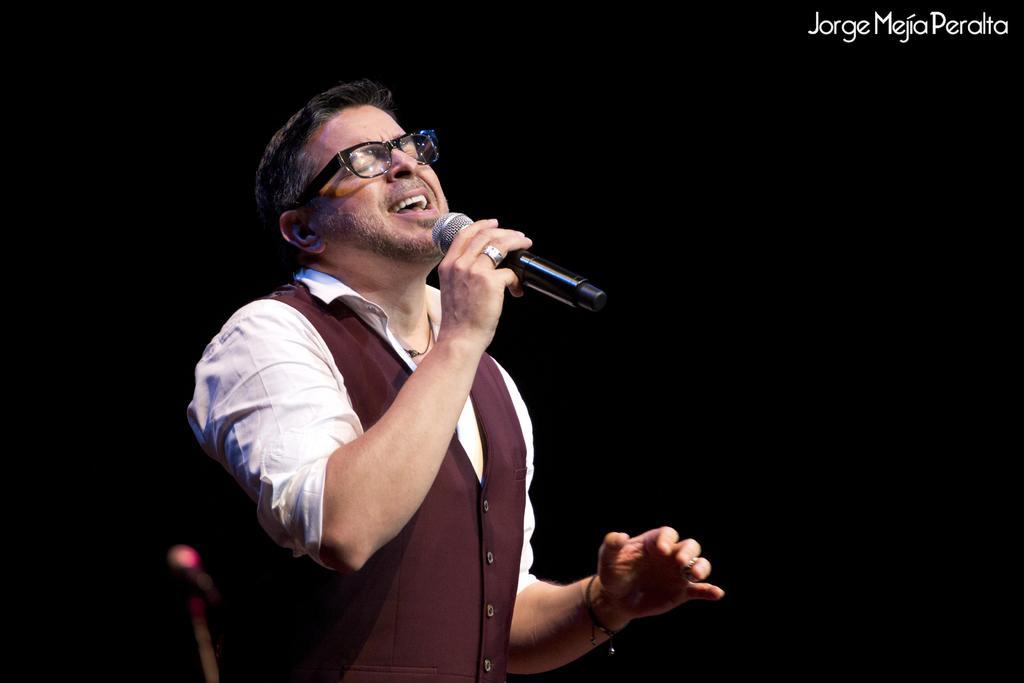Describe this image in one or two sentences. There is a man standing in the center. He is holding a microphone in his right hand and he is singing a song. 